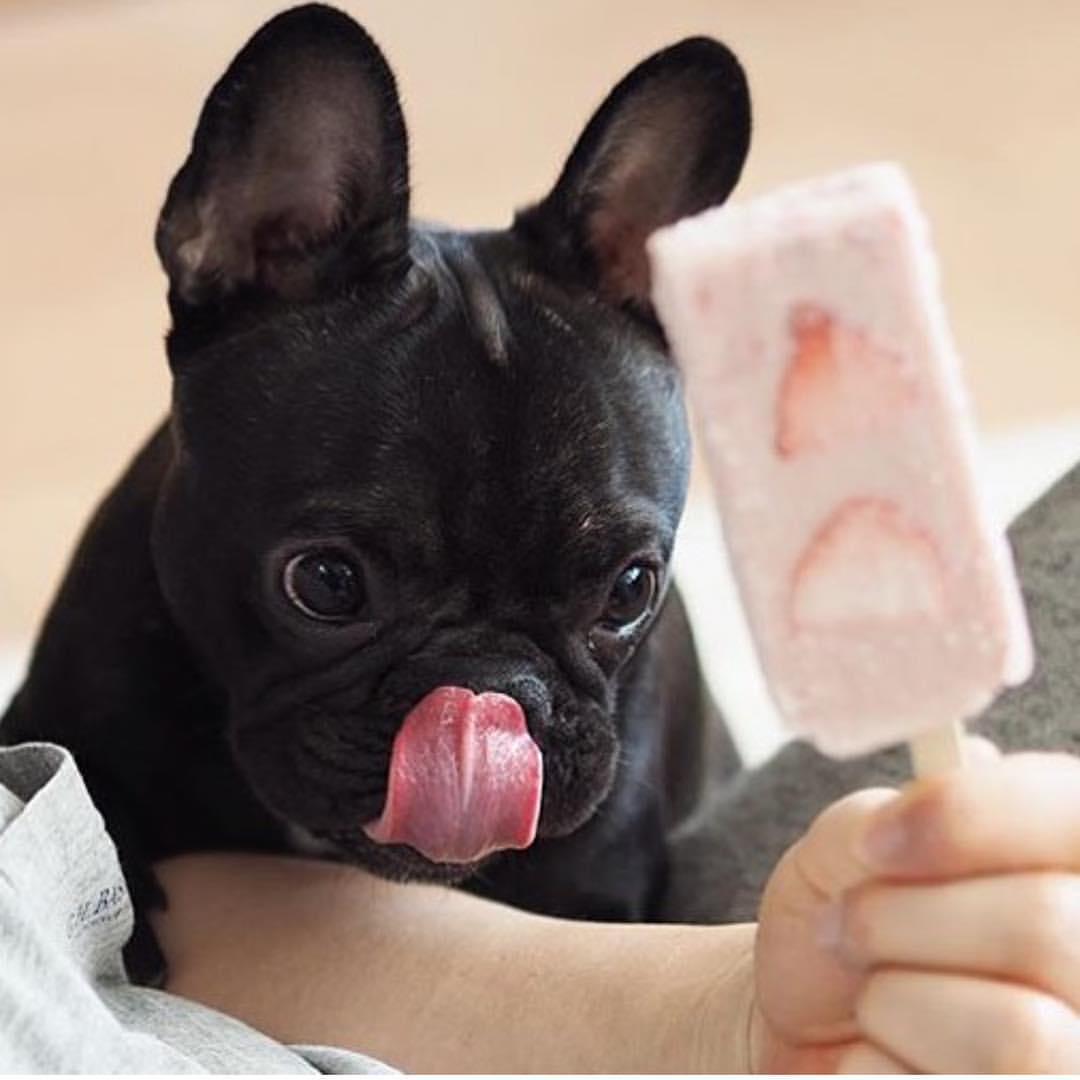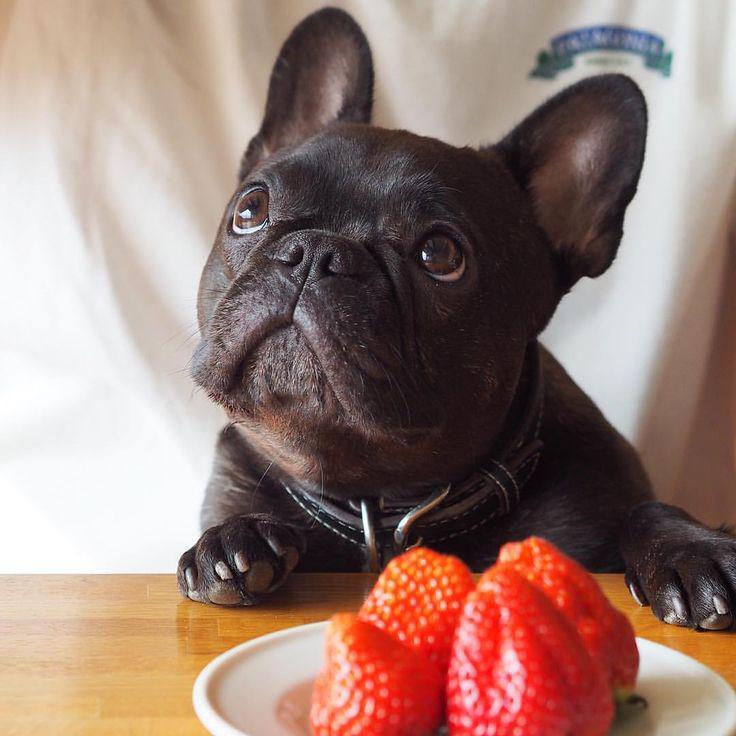The first image is the image on the left, the second image is the image on the right. Analyze the images presented: Is the assertion "The head of a dark big-eared dog is behind a container of fresh red fruit." valid? Answer yes or no. Yes. The first image is the image on the left, the second image is the image on the right. Examine the images to the left and right. Is the description "There is a serving of fresh fruit in front of a black puppy." accurate? Answer yes or no. Yes. 